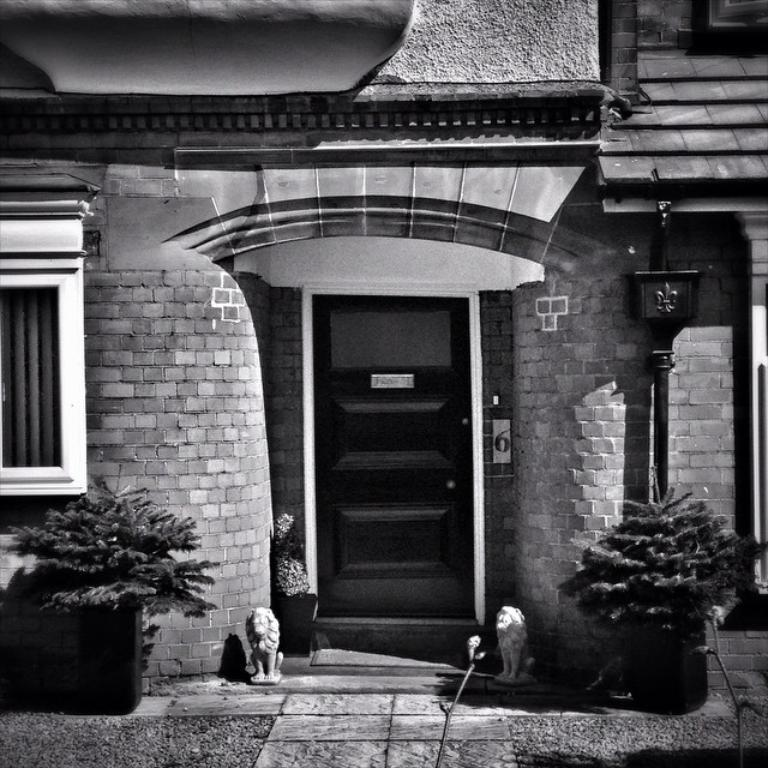What is the color scheme of the image? The image is black and white. What type of structure is visible in the image? There is a house in the image. What features can be seen on the house? The house has a door and a window. What decorative elements are present in front of the house? There are sculptures and plants in flower pots in front of the house. What type of pathway is in front of the house? There is a pathway in front of the house. What type of powder is being used to clean the sculptures in the image? There is no indication of any cleaning activity or powder in the image. Is there a throne visible in the image? No, there is no throne present in the image. 